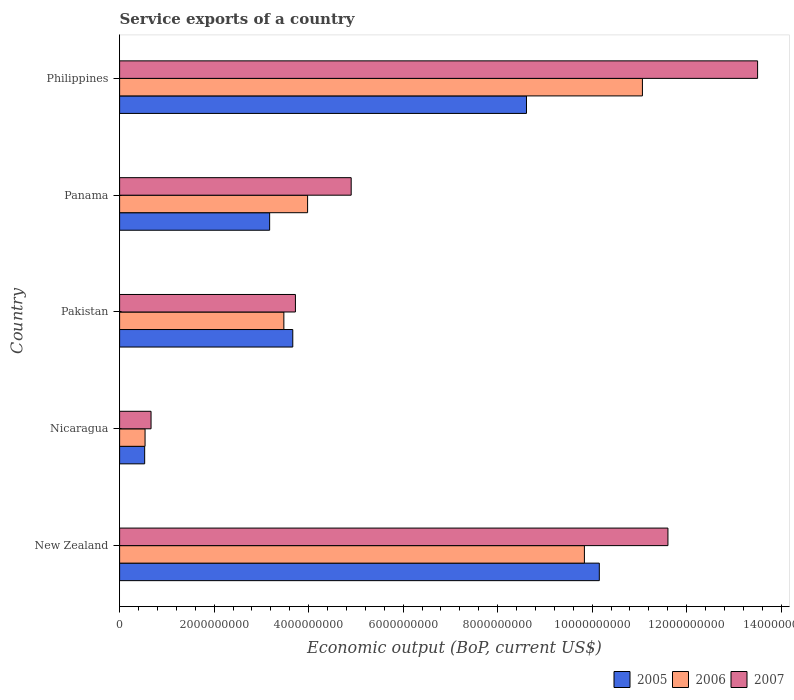How many groups of bars are there?
Provide a short and direct response. 5. Are the number of bars per tick equal to the number of legend labels?
Give a very brief answer. Yes. How many bars are there on the 1st tick from the bottom?
Your response must be concise. 3. What is the label of the 5th group of bars from the top?
Your answer should be compact. New Zealand. In how many cases, is the number of bars for a given country not equal to the number of legend labels?
Offer a terse response. 0. What is the service exports in 2005 in Philippines?
Offer a terse response. 8.61e+09. Across all countries, what is the maximum service exports in 2006?
Your answer should be compact. 1.11e+1. Across all countries, what is the minimum service exports in 2006?
Give a very brief answer. 5.39e+08. In which country was the service exports in 2007 maximum?
Your response must be concise. Philippines. In which country was the service exports in 2007 minimum?
Give a very brief answer. Nicaragua. What is the total service exports in 2005 in the graph?
Your answer should be compact. 2.61e+1. What is the difference between the service exports in 2006 in Nicaragua and that in Panama?
Offer a very short reply. -3.44e+09. What is the difference between the service exports in 2006 in Panama and the service exports in 2007 in Pakistan?
Ensure brevity in your answer.  2.58e+08. What is the average service exports in 2006 per country?
Your answer should be compact. 5.78e+09. What is the difference between the service exports in 2005 and service exports in 2006 in Pakistan?
Your response must be concise. 1.89e+08. What is the ratio of the service exports in 2007 in Pakistan to that in Philippines?
Ensure brevity in your answer.  0.28. Is the difference between the service exports in 2005 in Panama and Philippines greater than the difference between the service exports in 2006 in Panama and Philippines?
Keep it short and to the point. Yes. What is the difference between the highest and the second highest service exports in 2007?
Offer a terse response. 1.90e+09. What is the difference between the highest and the lowest service exports in 2006?
Offer a very short reply. 1.05e+1. In how many countries, is the service exports in 2006 greater than the average service exports in 2006 taken over all countries?
Make the answer very short. 2. What does the 3rd bar from the top in Nicaragua represents?
Your answer should be compact. 2005. Is it the case that in every country, the sum of the service exports in 2007 and service exports in 2005 is greater than the service exports in 2006?
Give a very brief answer. Yes. How many bars are there?
Your response must be concise. 15. What is the difference between two consecutive major ticks on the X-axis?
Make the answer very short. 2.00e+09. Are the values on the major ticks of X-axis written in scientific E-notation?
Your answer should be very brief. No. Does the graph contain any zero values?
Provide a succinct answer. No. How are the legend labels stacked?
Your response must be concise. Horizontal. What is the title of the graph?
Ensure brevity in your answer.  Service exports of a country. Does "1971" appear as one of the legend labels in the graph?
Offer a very short reply. No. What is the label or title of the X-axis?
Offer a very short reply. Economic output (BoP, current US$). What is the label or title of the Y-axis?
Your answer should be very brief. Country. What is the Economic output (BoP, current US$) of 2005 in New Zealand?
Make the answer very short. 1.02e+1. What is the Economic output (BoP, current US$) in 2006 in New Zealand?
Your response must be concise. 9.84e+09. What is the Economic output (BoP, current US$) of 2007 in New Zealand?
Make the answer very short. 1.16e+1. What is the Economic output (BoP, current US$) of 2005 in Nicaragua?
Offer a very short reply. 5.31e+08. What is the Economic output (BoP, current US$) in 2006 in Nicaragua?
Your answer should be very brief. 5.39e+08. What is the Economic output (BoP, current US$) of 2007 in Nicaragua?
Your answer should be very brief. 6.66e+08. What is the Economic output (BoP, current US$) of 2005 in Pakistan?
Offer a terse response. 3.66e+09. What is the Economic output (BoP, current US$) of 2006 in Pakistan?
Make the answer very short. 3.48e+09. What is the Economic output (BoP, current US$) of 2007 in Pakistan?
Provide a succinct answer. 3.72e+09. What is the Economic output (BoP, current US$) in 2005 in Panama?
Give a very brief answer. 3.18e+09. What is the Economic output (BoP, current US$) of 2006 in Panama?
Ensure brevity in your answer.  3.98e+09. What is the Economic output (BoP, current US$) in 2007 in Panama?
Keep it short and to the point. 4.90e+09. What is the Economic output (BoP, current US$) of 2005 in Philippines?
Your response must be concise. 8.61e+09. What is the Economic output (BoP, current US$) in 2006 in Philippines?
Provide a short and direct response. 1.11e+1. What is the Economic output (BoP, current US$) of 2007 in Philippines?
Keep it short and to the point. 1.35e+1. Across all countries, what is the maximum Economic output (BoP, current US$) in 2005?
Make the answer very short. 1.02e+1. Across all countries, what is the maximum Economic output (BoP, current US$) in 2006?
Offer a terse response. 1.11e+1. Across all countries, what is the maximum Economic output (BoP, current US$) in 2007?
Ensure brevity in your answer.  1.35e+1. Across all countries, what is the minimum Economic output (BoP, current US$) in 2005?
Provide a short and direct response. 5.31e+08. Across all countries, what is the minimum Economic output (BoP, current US$) in 2006?
Keep it short and to the point. 5.39e+08. Across all countries, what is the minimum Economic output (BoP, current US$) of 2007?
Keep it short and to the point. 6.66e+08. What is the total Economic output (BoP, current US$) of 2005 in the graph?
Offer a terse response. 2.61e+1. What is the total Economic output (BoP, current US$) in 2006 in the graph?
Offer a terse response. 2.89e+1. What is the total Economic output (BoP, current US$) of 2007 in the graph?
Your answer should be very brief. 3.44e+1. What is the difference between the Economic output (BoP, current US$) of 2005 in New Zealand and that in Nicaragua?
Ensure brevity in your answer.  9.62e+09. What is the difference between the Economic output (BoP, current US$) of 2006 in New Zealand and that in Nicaragua?
Provide a succinct answer. 9.30e+09. What is the difference between the Economic output (BoP, current US$) of 2007 in New Zealand and that in Nicaragua?
Provide a succinct answer. 1.09e+1. What is the difference between the Economic output (BoP, current US$) of 2005 in New Zealand and that in Pakistan?
Provide a succinct answer. 6.49e+09. What is the difference between the Economic output (BoP, current US$) in 2006 in New Zealand and that in Pakistan?
Your answer should be very brief. 6.36e+09. What is the difference between the Economic output (BoP, current US$) of 2007 in New Zealand and that in Pakistan?
Your answer should be very brief. 7.88e+09. What is the difference between the Economic output (BoP, current US$) in 2005 in New Zealand and that in Panama?
Your answer should be very brief. 6.98e+09. What is the difference between the Economic output (BoP, current US$) of 2006 in New Zealand and that in Panama?
Keep it short and to the point. 5.86e+09. What is the difference between the Economic output (BoP, current US$) of 2007 in New Zealand and that in Panama?
Your answer should be compact. 6.70e+09. What is the difference between the Economic output (BoP, current US$) in 2005 in New Zealand and that in Philippines?
Your response must be concise. 1.54e+09. What is the difference between the Economic output (BoP, current US$) of 2006 in New Zealand and that in Philippines?
Give a very brief answer. -1.23e+09. What is the difference between the Economic output (BoP, current US$) in 2007 in New Zealand and that in Philippines?
Offer a terse response. -1.90e+09. What is the difference between the Economic output (BoP, current US$) of 2005 in Nicaragua and that in Pakistan?
Your answer should be very brief. -3.13e+09. What is the difference between the Economic output (BoP, current US$) in 2006 in Nicaragua and that in Pakistan?
Your answer should be very brief. -2.94e+09. What is the difference between the Economic output (BoP, current US$) in 2007 in Nicaragua and that in Pakistan?
Keep it short and to the point. -3.06e+09. What is the difference between the Economic output (BoP, current US$) of 2005 in Nicaragua and that in Panama?
Make the answer very short. -2.64e+09. What is the difference between the Economic output (BoP, current US$) in 2006 in Nicaragua and that in Panama?
Keep it short and to the point. -3.44e+09. What is the difference between the Economic output (BoP, current US$) of 2007 in Nicaragua and that in Panama?
Offer a terse response. -4.24e+09. What is the difference between the Economic output (BoP, current US$) in 2005 in Nicaragua and that in Philippines?
Your answer should be compact. -8.08e+09. What is the difference between the Economic output (BoP, current US$) in 2006 in Nicaragua and that in Philippines?
Ensure brevity in your answer.  -1.05e+1. What is the difference between the Economic output (BoP, current US$) in 2007 in Nicaragua and that in Philippines?
Your answer should be compact. -1.28e+1. What is the difference between the Economic output (BoP, current US$) in 2005 in Pakistan and that in Panama?
Keep it short and to the point. 4.90e+08. What is the difference between the Economic output (BoP, current US$) in 2006 in Pakistan and that in Panama?
Provide a short and direct response. -5.02e+08. What is the difference between the Economic output (BoP, current US$) in 2007 in Pakistan and that in Panama?
Keep it short and to the point. -1.18e+09. What is the difference between the Economic output (BoP, current US$) of 2005 in Pakistan and that in Philippines?
Make the answer very short. -4.95e+09. What is the difference between the Economic output (BoP, current US$) in 2006 in Pakistan and that in Philippines?
Offer a very short reply. -7.59e+09. What is the difference between the Economic output (BoP, current US$) in 2007 in Pakistan and that in Philippines?
Give a very brief answer. -9.78e+09. What is the difference between the Economic output (BoP, current US$) of 2005 in Panama and that in Philippines?
Your answer should be compact. -5.44e+09. What is the difference between the Economic output (BoP, current US$) of 2006 in Panama and that in Philippines?
Offer a terse response. -7.09e+09. What is the difference between the Economic output (BoP, current US$) in 2007 in Panama and that in Philippines?
Make the answer very short. -8.60e+09. What is the difference between the Economic output (BoP, current US$) of 2005 in New Zealand and the Economic output (BoP, current US$) of 2006 in Nicaragua?
Provide a short and direct response. 9.61e+09. What is the difference between the Economic output (BoP, current US$) in 2005 in New Zealand and the Economic output (BoP, current US$) in 2007 in Nicaragua?
Your response must be concise. 9.49e+09. What is the difference between the Economic output (BoP, current US$) of 2006 in New Zealand and the Economic output (BoP, current US$) of 2007 in Nicaragua?
Keep it short and to the point. 9.17e+09. What is the difference between the Economic output (BoP, current US$) in 2005 in New Zealand and the Economic output (BoP, current US$) in 2006 in Pakistan?
Give a very brief answer. 6.68e+09. What is the difference between the Economic output (BoP, current US$) in 2005 in New Zealand and the Economic output (BoP, current US$) in 2007 in Pakistan?
Give a very brief answer. 6.43e+09. What is the difference between the Economic output (BoP, current US$) in 2006 in New Zealand and the Economic output (BoP, current US$) in 2007 in Pakistan?
Offer a terse response. 6.12e+09. What is the difference between the Economic output (BoP, current US$) in 2005 in New Zealand and the Economic output (BoP, current US$) in 2006 in Panama?
Your answer should be compact. 6.17e+09. What is the difference between the Economic output (BoP, current US$) of 2005 in New Zealand and the Economic output (BoP, current US$) of 2007 in Panama?
Offer a terse response. 5.25e+09. What is the difference between the Economic output (BoP, current US$) of 2006 in New Zealand and the Economic output (BoP, current US$) of 2007 in Panama?
Ensure brevity in your answer.  4.94e+09. What is the difference between the Economic output (BoP, current US$) in 2005 in New Zealand and the Economic output (BoP, current US$) in 2006 in Philippines?
Keep it short and to the point. -9.12e+08. What is the difference between the Economic output (BoP, current US$) of 2005 in New Zealand and the Economic output (BoP, current US$) of 2007 in Philippines?
Your answer should be very brief. -3.35e+09. What is the difference between the Economic output (BoP, current US$) of 2006 in New Zealand and the Economic output (BoP, current US$) of 2007 in Philippines?
Provide a short and direct response. -3.67e+09. What is the difference between the Economic output (BoP, current US$) in 2005 in Nicaragua and the Economic output (BoP, current US$) in 2006 in Pakistan?
Provide a short and direct response. -2.95e+09. What is the difference between the Economic output (BoP, current US$) in 2005 in Nicaragua and the Economic output (BoP, current US$) in 2007 in Pakistan?
Make the answer very short. -3.19e+09. What is the difference between the Economic output (BoP, current US$) of 2006 in Nicaragua and the Economic output (BoP, current US$) of 2007 in Pakistan?
Offer a very short reply. -3.18e+09. What is the difference between the Economic output (BoP, current US$) of 2005 in Nicaragua and the Economic output (BoP, current US$) of 2006 in Panama?
Provide a succinct answer. -3.45e+09. What is the difference between the Economic output (BoP, current US$) in 2005 in Nicaragua and the Economic output (BoP, current US$) in 2007 in Panama?
Offer a very short reply. -4.37e+09. What is the difference between the Economic output (BoP, current US$) in 2006 in Nicaragua and the Economic output (BoP, current US$) in 2007 in Panama?
Keep it short and to the point. -4.36e+09. What is the difference between the Economic output (BoP, current US$) of 2005 in Nicaragua and the Economic output (BoP, current US$) of 2006 in Philippines?
Keep it short and to the point. -1.05e+1. What is the difference between the Economic output (BoP, current US$) in 2005 in Nicaragua and the Economic output (BoP, current US$) in 2007 in Philippines?
Your answer should be very brief. -1.30e+1. What is the difference between the Economic output (BoP, current US$) in 2006 in Nicaragua and the Economic output (BoP, current US$) in 2007 in Philippines?
Provide a succinct answer. -1.30e+1. What is the difference between the Economic output (BoP, current US$) in 2005 in Pakistan and the Economic output (BoP, current US$) in 2006 in Panama?
Your response must be concise. -3.13e+08. What is the difference between the Economic output (BoP, current US$) in 2005 in Pakistan and the Economic output (BoP, current US$) in 2007 in Panama?
Offer a terse response. -1.24e+09. What is the difference between the Economic output (BoP, current US$) of 2006 in Pakistan and the Economic output (BoP, current US$) of 2007 in Panama?
Provide a short and direct response. -1.42e+09. What is the difference between the Economic output (BoP, current US$) in 2005 in Pakistan and the Economic output (BoP, current US$) in 2006 in Philippines?
Ensure brevity in your answer.  -7.40e+09. What is the difference between the Economic output (BoP, current US$) of 2005 in Pakistan and the Economic output (BoP, current US$) of 2007 in Philippines?
Make the answer very short. -9.84e+09. What is the difference between the Economic output (BoP, current US$) of 2006 in Pakistan and the Economic output (BoP, current US$) of 2007 in Philippines?
Your answer should be compact. -1.00e+1. What is the difference between the Economic output (BoP, current US$) in 2005 in Panama and the Economic output (BoP, current US$) in 2006 in Philippines?
Ensure brevity in your answer.  -7.89e+09. What is the difference between the Economic output (BoP, current US$) in 2005 in Panama and the Economic output (BoP, current US$) in 2007 in Philippines?
Keep it short and to the point. -1.03e+1. What is the difference between the Economic output (BoP, current US$) of 2006 in Panama and the Economic output (BoP, current US$) of 2007 in Philippines?
Your answer should be very brief. -9.52e+09. What is the average Economic output (BoP, current US$) of 2005 per country?
Ensure brevity in your answer.  5.23e+09. What is the average Economic output (BoP, current US$) of 2006 per country?
Offer a very short reply. 5.78e+09. What is the average Economic output (BoP, current US$) of 2007 per country?
Ensure brevity in your answer.  6.88e+09. What is the difference between the Economic output (BoP, current US$) of 2005 and Economic output (BoP, current US$) of 2006 in New Zealand?
Provide a succinct answer. 3.15e+08. What is the difference between the Economic output (BoP, current US$) of 2005 and Economic output (BoP, current US$) of 2007 in New Zealand?
Offer a terse response. -1.45e+09. What is the difference between the Economic output (BoP, current US$) in 2006 and Economic output (BoP, current US$) in 2007 in New Zealand?
Your answer should be very brief. -1.77e+09. What is the difference between the Economic output (BoP, current US$) of 2005 and Economic output (BoP, current US$) of 2006 in Nicaragua?
Offer a terse response. -8.00e+06. What is the difference between the Economic output (BoP, current US$) in 2005 and Economic output (BoP, current US$) in 2007 in Nicaragua?
Ensure brevity in your answer.  -1.35e+08. What is the difference between the Economic output (BoP, current US$) of 2006 and Economic output (BoP, current US$) of 2007 in Nicaragua?
Offer a very short reply. -1.27e+08. What is the difference between the Economic output (BoP, current US$) of 2005 and Economic output (BoP, current US$) of 2006 in Pakistan?
Provide a succinct answer. 1.89e+08. What is the difference between the Economic output (BoP, current US$) in 2005 and Economic output (BoP, current US$) in 2007 in Pakistan?
Ensure brevity in your answer.  -5.57e+07. What is the difference between the Economic output (BoP, current US$) in 2006 and Economic output (BoP, current US$) in 2007 in Pakistan?
Give a very brief answer. -2.45e+08. What is the difference between the Economic output (BoP, current US$) in 2005 and Economic output (BoP, current US$) in 2006 in Panama?
Provide a succinct answer. -8.03e+08. What is the difference between the Economic output (BoP, current US$) in 2005 and Economic output (BoP, current US$) in 2007 in Panama?
Your answer should be compact. -1.73e+09. What is the difference between the Economic output (BoP, current US$) in 2006 and Economic output (BoP, current US$) in 2007 in Panama?
Offer a very short reply. -9.22e+08. What is the difference between the Economic output (BoP, current US$) in 2005 and Economic output (BoP, current US$) in 2006 in Philippines?
Provide a succinct answer. -2.45e+09. What is the difference between the Economic output (BoP, current US$) in 2005 and Economic output (BoP, current US$) in 2007 in Philippines?
Make the answer very short. -4.89e+09. What is the difference between the Economic output (BoP, current US$) in 2006 and Economic output (BoP, current US$) in 2007 in Philippines?
Your response must be concise. -2.44e+09. What is the ratio of the Economic output (BoP, current US$) in 2005 in New Zealand to that in Nicaragua?
Make the answer very short. 19.13. What is the ratio of the Economic output (BoP, current US$) of 2006 in New Zealand to that in Nicaragua?
Your answer should be very brief. 18.26. What is the ratio of the Economic output (BoP, current US$) in 2007 in New Zealand to that in Nicaragua?
Make the answer very short. 17.43. What is the ratio of the Economic output (BoP, current US$) of 2005 in New Zealand to that in Pakistan?
Provide a succinct answer. 2.77. What is the ratio of the Economic output (BoP, current US$) in 2006 in New Zealand to that in Pakistan?
Offer a terse response. 2.83. What is the ratio of the Economic output (BoP, current US$) of 2007 in New Zealand to that in Pakistan?
Your answer should be compact. 3.12. What is the ratio of the Economic output (BoP, current US$) of 2005 in New Zealand to that in Panama?
Offer a very short reply. 3.2. What is the ratio of the Economic output (BoP, current US$) of 2006 in New Zealand to that in Panama?
Make the answer very short. 2.47. What is the ratio of the Economic output (BoP, current US$) of 2007 in New Zealand to that in Panama?
Provide a succinct answer. 2.37. What is the ratio of the Economic output (BoP, current US$) in 2005 in New Zealand to that in Philippines?
Offer a very short reply. 1.18. What is the ratio of the Economic output (BoP, current US$) of 2006 in New Zealand to that in Philippines?
Your answer should be compact. 0.89. What is the ratio of the Economic output (BoP, current US$) of 2007 in New Zealand to that in Philippines?
Offer a terse response. 0.86. What is the ratio of the Economic output (BoP, current US$) in 2005 in Nicaragua to that in Pakistan?
Offer a very short reply. 0.14. What is the ratio of the Economic output (BoP, current US$) in 2006 in Nicaragua to that in Pakistan?
Your answer should be very brief. 0.15. What is the ratio of the Economic output (BoP, current US$) of 2007 in Nicaragua to that in Pakistan?
Your response must be concise. 0.18. What is the ratio of the Economic output (BoP, current US$) in 2005 in Nicaragua to that in Panama?
Offer a very short reply. 0.17. What is the ratio of the Economic output (BoP, current US$) in 2006 in Nicaragua to that in Panama?
Keep it short and to the point. 0.14. What is the ratio of the Economic output (BoP, current US$) in 2007 in Nicaragua to that in Panama?
Your response must be concise. 0.14. What is the ratio of the Economic output (BoP, current US$) in 2005 in Nicaragua to that in Philippines?
Give a very brief answer. 0.06. What is the ratio of the Economic output (BoP, current US$) in 2006 in Nicaragua to that in Philippines?
Your answer should be very brief. 0.05. What is the ratio of the Economic output (BoP, current US$) of 2007 in Nicaragua to that in Philippines?
Your response must be concise. 0.05. What is the ratio of the Economic output (BoP, current US$) of 2005 in Pakistan to that in Panama?
Offer a terse response. 1.15. What is the ratio of the Economic output (BoP, current US$) of 2006 in Pakistan to that in Panama?
Keep it short and to the point. 0.87. What is the ratio of the Economic output (BoP, current US$) in 2007 in Pakistan to that in Panama?
Keep it short and to the point. 0.76. What is the ratio of the Economic output (BoP, current US$) in 2005 in Pakistan to that in Philippines?
Provide a succinct answer. 0.43. What is the ratio of the Economic output (BoP, current US$) in 2006 in Pakistan to that in Philippines?
Your answer should be very brief. 0.31. What is the ratio of the Economic output (BoP, current US$) in 2007 in Pakistan to that in Philippines?
Make the answer very short. 0.28. What is the ratio of the Economic output (BoP, current US$) in 2005 in Panama to that in Philippines?
Give a very brief answer. 0.37. What is the ratio of the Economic output (BoP, current US$) in 2006 in Panama to that in Philippines?
Ensure brevity in your answer.  0.36. What is the ratio of the Economic output (BoP, current US$) in 2007 in Panama to that in Philippines?
Provide a short and direct response. 0.36. What is the difference between the highest and the second highest Economic output (BoP, current US$) in 2005?
Keep it short and to the point. 1.54e+09. What is the difference between the highest and the second highest Economic output (BoP, current US$) in 2006?
Your response must be concise. 1.23e+09. What is the difference between the highest and the second highest Economic output (BoP, current US$) of 2007?
Offer a terse response. 1.90e+09. What is the difference between the highest and the lowest Economic output (BoP, current US$) in 2005?
Ensure brevity in your answer.  9.62e+09. What is the difference between the highest and the lowest Economic output (BoP, current US$) of 2006?
Offer a very short reply. 1.05e+1. What is the difference between the highest and the lowest Economic output (BoP, current US$) of 2007?
Offer a terse response. 1.28e+1. 